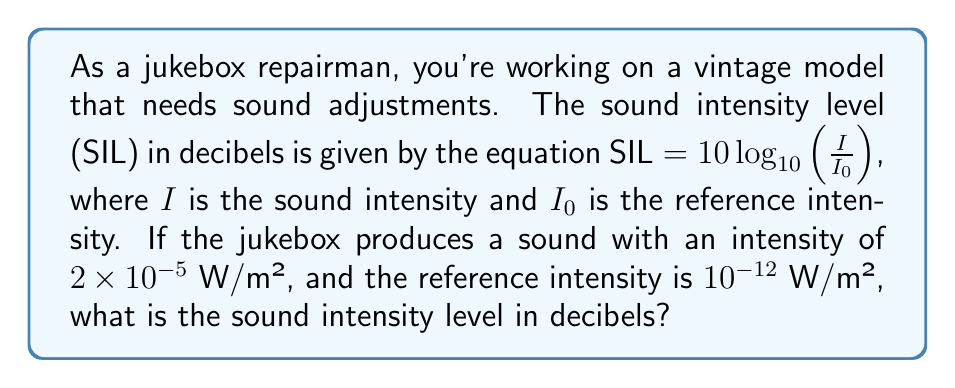Show me your answer to this math problem. Let's solve this step-by-step:

1) We're given the equation: $SIL = 10 \log_{10}(\frac{I}{I_0})$

2) We know:
   $I = 2 \times 10^{-5}$ W/m²
   $I_0 = 10^{-12}$ W/m²

3) Let's substitute these values into the equation:

   $SIL = 10 \log_{10}(\frac{2 \times 10^{-5}}{10^{-12}})$

4) Simplify inside the parentheses:
   
   $SIL = 10 \log_{10}(2 \times 10^7)$

5) Use the logarithm property $\log_a(x \cdot y) = \log_a(x) + \log_a(y)$:

   $SIL = 10 (\log_{10}(2) + \log_{10}(10^7))$

6) Simplify $\log_{10}(10^7) = 7$:

   $SIL = 10 (\log_{10}(2) + 7)$

7) Calculate $\log_{10}(2) \approx 0.301$:

   $SIL = 10 (0.301 + 7) = 10 (7.301) = 73.01$

Therefore, the sound intensity level is approximately 73.01 decibels.
Answer: 73.01 dB 